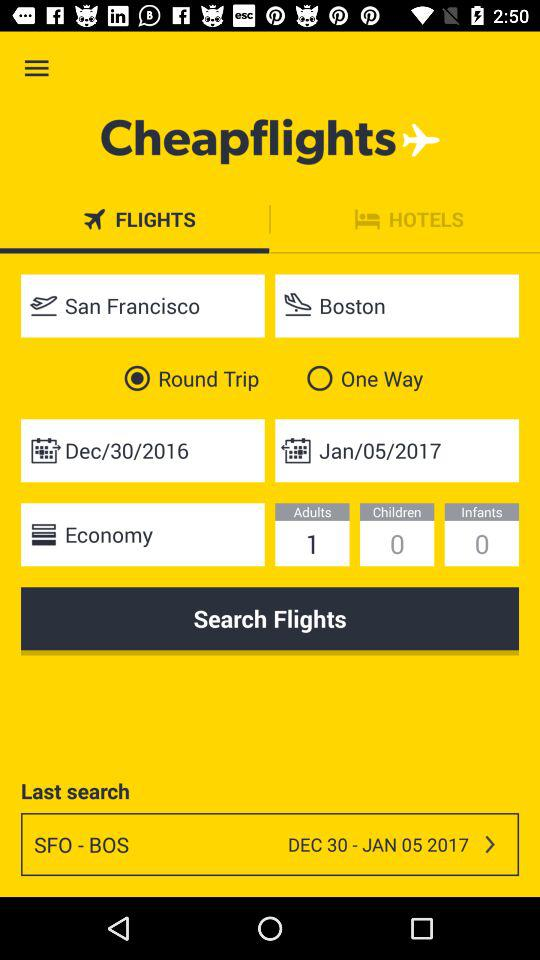What is the schedule of the last searched flight? The schedule is from December 30, 2016 to January 5, 2017. 